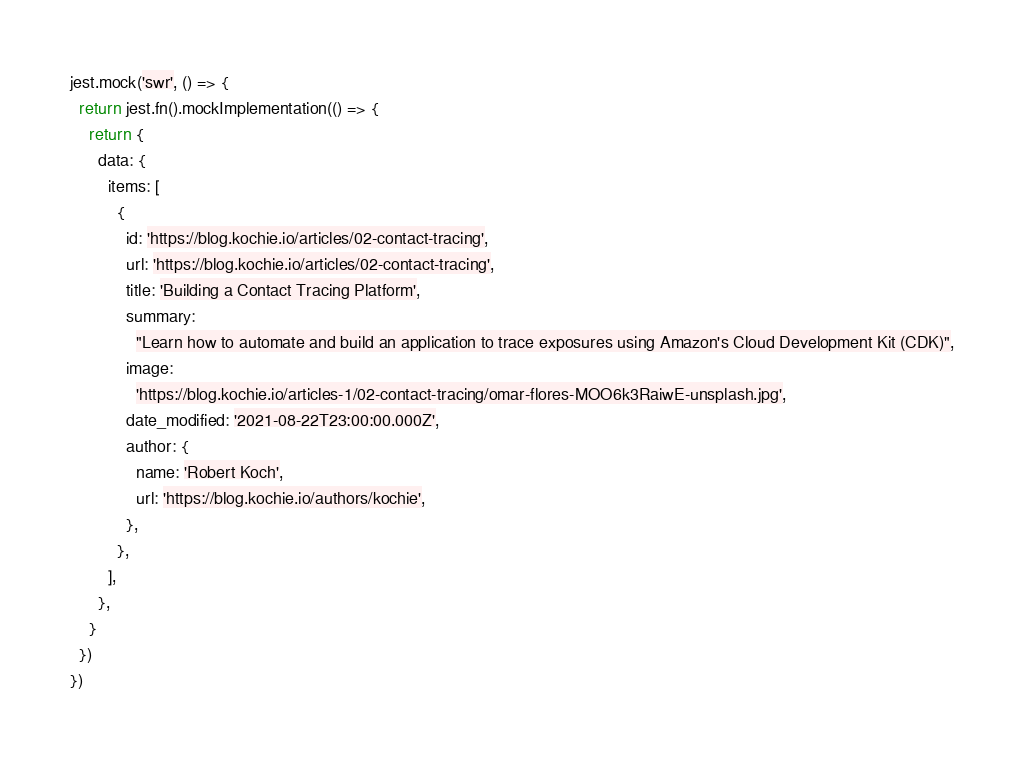Convert code to text. <code><loc_0><loc_0><loc_500><loc_500><_JavaScript_>jest.mock('swr', () => {
  return jest.fn().mockImplementation(() => {
    return {
      data: {
        items: [
          {
            id: 'https://blog.kochie.io/articles/02-contact-tracing',
            url: 'https://blog.kochie.io/articles/02-contact-tracing',
            title: 'Building a Contact Tracing Platform',
            summary:
              "Learn how to automate and build an application to trace exposures using Amazon's Cloud Development Kit (CDK)",
            image:
              'https://blog.kochie.io/articles-1/02-contact-tracing/omar-flores-MOO6k3RaiwE-unsplash.jpg',
            date_modified: '2021-08-22T23:00:00.000Z',
            author: {
              name: 'Robert Koch',
              url: 'https://blog.kochie.io/authors/kochie',
            },
          },
        ],
      },
    }
  })
})
</code> 